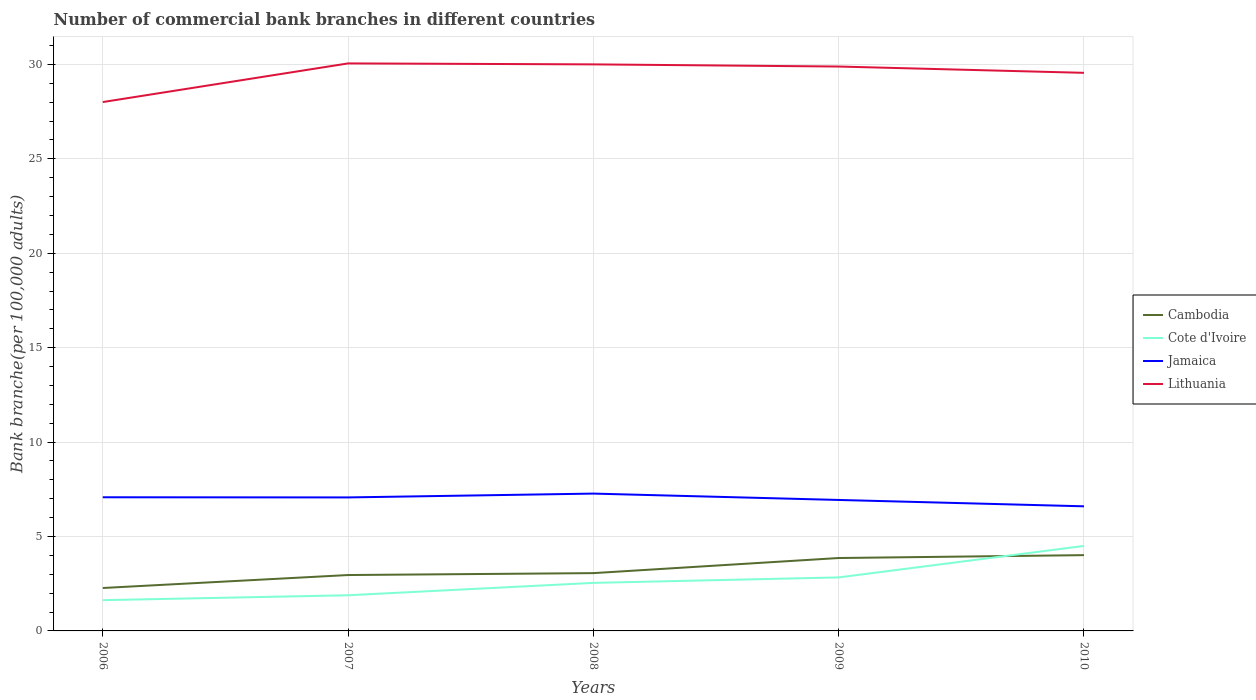Does the line corresponding to Cote d'Ivoire intersect with the line corresponding to Lithuania?
Offer a very short reply. No. Across all years, what is the maximum number of commercial bank branches in Cote d'Ivoire?
Make the answer very short. 1.63. What is the total number of commercial bank branches in Lithuania in the graph?
Offer a very short reply. -1.55. What is the difference between the highest and the second highest number of commercial bank branches in Cote d'Ivoire?
Keep it short and to the point. 2.87. Is the number of commercial bank branches in Cote d'Ivoire strictly greater than the number of commercial bank branches in Lithuania over the years?
Offer a very short reply. Yes. How many lines are there?
Offer a terse response. 4. How many years are there in the graph?
Provide a short and direct response. 5. What is the difference between two consecutive major ticks on the Y-axis?
Your answer should be very brief. 5. Does the graph contain any zero values?
Your response must be concise. No. Does the graph contain grids?
Keep it short and to the point. Yes. What is the title of the graph?
Provide a succinct answer. Number of commercial bank branches in different countries. Does "Australia" appear as one of the legend labels in the graph?
Provide a short and direct response. No. What is the label or title of the X-axis?
Keep it short and to the point. Years. What is the label or title of the Y-axis?
Your answer should be very brief. Bank branche(per 100,0 adults). What is the Bank branche(per 100,000 adults) in Cambodia in 2006?
Your answer should be compact. 2.27. What is the Bank branche(per 100,000 adults) in Cote d'Ivoire in 2006?
Offer a terse response. 1.63. What is the Bank branche(per 100,000 adults) of Jamaica in 2006?
Keep it short and to the point. 7.08. What is the Bank branche(per 100,000 adults) in Lithuania in 2006?
Your answer should be compact. 28.01. What is the Bank branche(per 100,000 adults) in Cambodia in 2007?
Provide a succinct answer. 2.96. What is the Bank branche(per 100,000 adults) of Cote d'Ivoire in 2007?
Your answer should be compact. 1.89. What is the Bank branche(per 100,000 adults) in Jamaica in 2007?
Offer a very short reply. 7.07. What is the Bank branche(per 100,000 adults) of Lithuania in 2007?
Your answer should be very brief. 30.05. What is the Bank branche(per 100,000 adults) in Cambodia in 2008?
Your response must be concise. 3.06. What is the Bank branche(per 100,000 adults) in Cote d'Ivoire in 2008?
Ensure brevity in your answer.  2.54. What is the Bank branche(per 100,000 adults) of Jamaica in 2008?
Your answer should be very brief. 7.27. What is the Bank branche(per 100,000 adults) of Lithuania in 2008?
Keep it short and to the point. 30. What is the Bank branche(per 100,000 adults) in Cambodia in 2009?
Keep it short and to the point. 3.86. What is the Bank branche(per 100,000 adults) in Cote d'Ivoire in 2009?
Ensure brevity in your answer.  2.83. What is the Bank branche(per 100,000 adults) in Jamaica in 2009?
Offer a very short reply. 6.94. What is the Bank branche(per 100,000 adults) in Lithuania in 2009?
Offer a terse response. 29.89. What is the Bank branche(per 100,000 adults) in Cambodia in 2010?
Offer a terse response. 4.01. What is the Bank branche(per 100,000 adults) of Cote d'Ivoire in 2010?
Make the answer very short. 4.5. What is the Bank branche(per 100,000 adults) in Jamaica in 2010?
Your answer should be compact. 6.6. What is the Bank branche(per 100,000 adults) in Lithuania in 2010?
Keep it short and to the point. 29.56. Across all years, what is the maximum Bank branche(per 100,000 adults) of Cambodia?
Ensure brevity in your answer.  4.01. Across all years, what is the maximum Bank branche(per 100,000 adults) in Cote d'Ivoire?
Offer a very short reply. 4.5. Across all years, what is the maximum Bank branche(per 100,000 adults) in Jamaica?
Offer a very short reply. 7.27. Across all years, what is the maximum Bank branche(per 100,000 adults) in Lithuania?
Make the answer very short. 30.05. Across all years, what is the minimum Bank branche(per 100,000 adults) in Cambodia?
Your answer should be very brief. 2.27. Across all years, what is the minimum Bank branche(per 100,000 adults) in Cote d'Ivoire?
Offer a very short reply. 1.63. Across all years, what is the minimum Bank branche(per 100,000 adults) in Jamaica?
Give a very brief answer. 6.6. Across all years, what is the minimum Bank branche(per 100,000 adults) of Lithuania?
Provide a short and direct response. 28.01. What is the total Bank branche(per 100,000 adults) in Cambodia in the graph?
Your answer should be very brief. 16.17. What is the total Bank branche(per 100,000 adults) in Cote d'Ivoire in the graph?
Ensure brevity in your answer.  13.4. What is the total Bank branche(per 100,000 adults) in Jamaica in the graph?
Keep it short and to the point. 34.95. What is the total Bank branche(per 100,000 adults) in Lithuania in the graph?
Keep it short and to the point. 147.51. What is the difference between the Bank branche(per 100,000 adults) in Cambodia in 2006 and that in 2007?
Ensure brevity in your answer.  -0.69. What is the difference between the Bank branche(per 100,000 adults) in Cote d'Ivoire in 2006 and that in 2007?
Give a very brief answer. -0.26. What is the difference between the Bank branche(per 100,000 adults) of Jamaica in 2006 and that in 2007?
Provide a short and direct response. 0.01. What is the difference between the Bank branche(per 100,000 adults) in Lithuania in 2006 and that in 2007?
Make the answer very short. -2.05. What is the difference between the Bank branche(per 100,000 adults) of Cambodia in 2006 and that in 2008?
Make the answer very short. -0.79. What is the difference between the Bank branche(per 100,000 adults) of Cote d'Ivoire in 2006 and that in 2008?
Your answer should be very brief. -0.92. What is the difference between the Bank branche(per 100,000 adults) of Jamaica in 2006 and that in 2008?
Your answer should be compact. -0.19. What is the difference between the Bank branche(per 100,000 adults) in Lithuania in 2006 and that in 2008?
Make the answer very short. -2. What is the difference between the Bank branche(per 100,000 adults) of Cambodia in 2006 and that in 2009?
Provide a short and direct response. -1.59. What is the difference between the Bank branche(per 100,000 adults) of Cote d'Ivoire in 2006 and that in 2009?
Provide a succinct answer. -1.21. What is the difference between the Bank branche(per 100,000 adults) of Jamaica in 2006 and that in 2009?
Provide a succinct answer. 0.14. What is the difference between the Bank branche(per 100,000 adults) in Lithuania in 2006 and that in 2009?
Ensure brevity in your answer.  -1.88. What is the difference between the Bank branche(per 100,000 adults) in Cambodia in 2006 and that in 2010?
Your response must be concise. -1.74. What is the difference between the Bank branche(per 100,000 adults) of Cote d'Ivoire in 2006 and that in 2010?
Make the answer very short. -2.87. What is the difference between the Bank branche(per 100,000 adults) in Jamaica in 2006 and that in 2010?
Keep it short and to the point. 0.48. What is the difference between the Bank branche(per 100,000 adults) in Lithuania in 2006 and that in 2010?
Ensure brevity in your answer.  -1.55. What is the difference between the Bank branche(per 100,000 adults) in Cambodia in 2007 and that in 2008?
Offer a very short reply. -0.1. What is the difference between the Bank branche(per 100,000 adults) in Cote d'Ivoire in 2007 and that in 2008?
Give a very brief answer. -0.65. What is the difference between the Bank branche(per 100,000 adults) of Jamaica in 2007 and that in 2008?
Make the answer very short. -0.2. What is the difference between the Bank branche(per 100,000 adults) of Lithuania in 2007 and that in 2008?
Your response must be concise. 0.05. What is the difference between the Bank branche(per 100,000 adults) in Cambodia in 2007 and that in 2009?
Your answer should be very brief. -0.9. What is the difference between the Bank branche(per 100,000 adults) in Cote d'Ivoire in 2007 and that in 2009?
Your answer should be very brief. -0.94. What is the difference between the Bank branche(per 100,000 adults) in Jamaica in 2007 and that in 2009?
Ensure brevity in your answer.  0.13. What is the difference between the Bank branche(per 100,000 adults) in Lithuania in 2007 and that in 2009?
Offer a terse response. 0.16. What is the difference between the Bank branche(per 100,000 adults) of Cambodia in 2007 and that in 2010?
Your answer should be compact. -1.05. What is the difference between the Bank branche(per 100,000 adults) of Cote d'Ivoire in 2007 and that in 2010?
Provide a short and direct response. -2.61. What is the difference between the Bank branche(per 100,000 adults) in Jamaica in 2007 and that in 2010?
Keep it short and to the point. 0.47. What is the difference between the Bank branche(per 100,000 adults) in Lithuania in 2007 and that in 2010?
Provide a succinct answer. 0.5. What is the difference between the Bank branche(per 100,000 adults) of Cambodia in 2008 and that in 2009?
Provide a short and direct response. -0.8. What is the difference between the Bank branche(per 100,000 adults) in Cote d'Ivoire in 2008 and that in 2009?
Make the answer very short. -0.29. What is the difference between the Bank branche(per 100,000 adults) in Jamaica in 2008 and that in 2009?
Your answer should be very brief. 0.34. What is the difference between the Bank branche(per 100,000 adults) of Lithuania in 2008 and that in 2009?
Ensure brevity in your answer.  0.11. What is the difference between the Bank branche(per 100,000 adults) in Cambodia in 2008 and that in 2010?
Ensure brevity in your answer.  -0.95. What is the difference between the Bank branche(per 100,000 adults) in Cote d'Ivoire in 2008 and that in 2010?
Your response must be concise. -1.96. What is the difference between the Bank branche(per 100,000 adults) of Jamaica in 2008 and that in 2010?
Your response must be concise. 0.67. What is the difference between the Bank branche(per 100,000 adults) of Lithuania in 2008 and that in 2010?
Provide a short and direct response. 0.45. What is the difference between the Bank branche(per 100,000 adults) of Cambodia in 2009 and that in 2010?
Offer a very short reply. -0.15. What is the difference between the Bank branche(per 100,000 adults) of Cote d'Ivoire in 2009 and that in 2010?
Your answer should be compact. -1.67. What is the difference between the Bank branche(per 100,000 adults) of Jamaica in 2009 and that in 2010?
Give a very brief answer. 0.34. What is the difference between the Bank branche(per 100,000 adults) of Lithuania in 2009 and that in 2010?
Give a very brief answer. 0.33. What is the difference between the Bank branche(per 100,000 adults) of Cambodia in 2006 and the Bank branche(per 100,000 adults) of Cote d'Ivoire in 2007?
Give a very brief answer. 0.38. What is the difference between the Bank branche(per 100,000 adults) in Cambodia in 2006 and the Bank branche(per 100,000 adults) in Jamaica in 2007?
Offer a very short reply. -4.8. What is the difference between the Bank branche(per 100,000 adults) in Cambodia in 2006 and the Bank branche(per 100,000 adults) in Lithuania in 2007?
Your answer should be very brief. -27.78. What is the difference between the Bank branche(per 100,000 adults) in Cote d'Ivoire in 2006 and the Bank branche(per 100,000 adults) in Jamaica in 2007?
Offer a very short reply. -5.44. What is the difference between the Bank branche(per 100,000 adults) in Cote d'Ivoire in 2006 and the Bank branche(per 100,000 adults) in Lithuania in 2007?
Ensure brevity in your answer.  -28.43. What is the difference between the Bank branche(per 100,000 adults) in Jamaica in 2006 and the Bank branche(per 100,000 adults) in Lithuania in 2007?
Provide a short and direct response. -22.98. What is the difference between the Bank branche(per 100,000 adults) in Cambodia in 2006 and the Bank branche(per 100,000 adults) in Cote d'Ivoire in 2008?
Keep it short and to the point. -0.27. What is the difference between the Bank branche(per 100,000 adults) in Cambodia in 2006 and the Bank branche(per 100,000 adults) in Jamaica in 2008?
Keep it short and to the point. -5. What is the difference between the Bank branche(per 100,000 adults) of Cambodia in 2006 and the Bank branche(per 100,000 adults) of Lithuania in 2008?
Give a very brief answer. -27.73. What is the difference between the Bank branche(per 100,000 adults) in Cote d'Ivoire in 2006 and the Bank branche(per 100,000 adults) in Jamaica in 2008?
Provide a succinct answer. -5.64. What is the difference between the Bank branche(per 100,000 adults) of Cote d'Ivoire in 2006 and the Bank branche(per 100,000 adults) of Lithuania in 2008?
Offer a terse response. -28.38. What is the difference between the Bank branche(per 100,000 adults) in Jamaica in 2006 and the Bank branche(per 100,000 adults) in Lithuania in 2008?
Give a very brief answer. -22.93. What is the difference between the Bank branche(per 100,000 adults) in Cambodia in 2006 and the Bank branche(per 100,000 adults) in Cote d'Ivoire in 2009?
Offer a very short reply. -0.56. What is the difference between the Bank branche(per 100,000 adults) of Cambodia in 2006 and the Bank branche(per 100,000 adults) of Jamaica in 2009?
Give a very brief answer. -4.66. What is the difference between the Bank branche(per 100,000 adults) in Cambodia in 2006 and the Bank branche(per 100,000 adults) in Lithuania in 2009?
Your response must be concise. -27.62. What is the difference between the Bank branche(per 100,000 adults) of Cote d'Ivoire in 2006 and the Bank branche(per 100,000 adults) of Jamaica in 2009?
Provide a short and direct response. -5.31. What is the difference between the Bank branche(per 100,000 adults) in Cote d'Ivoire in 2006 and the Bank branche(per 100,000 adults) in Lithuania in 2009?
Provide a succinct answer. -28.26. What is the difference between the Bank branche(per 100,000 adults) in Jamaica in 2006 and the Bank branche(per 100,000 adults) in Lithuania in 2009?
Offer a very short reply. -22.81. What is the difference between the Bank branche(per 100,000 adults) in Cambodia in 2006 and the Bank branche(per 100,000 adults) in Cote d'Ivoire in 2010?
Your answer should be very brief. -2.23. What is the difference between the Bank branche(per 100,000 adults) in Cambodia in 2006 and the Bank branche(per 100,000 adults) in Jamaica in 2010?
Make the answer very short. -4.33. What is the difference between the Bank branche(per 100,000 adults) of Cambodia in 2006 and the Bank branche(per 100,000 adults) of Lithuania in 2010?
Your response must be concise. -27.28. What is the difference between the Bank branche(per 100,000 adults) in Cote d'Ivoire in 2006 and the Bank branche(per 100,000 adults) in Jamaica in 2010?
Your response must be concise. -4.97. What is the difference between the Bank branche(per 100,000 adults) in Cote d'Ivoire in 2006 and the Bank branche(per 100,000 adults) in Lithuania in 2010?
Keep it short and to the point. -27.93. What is the difference between the Bank branche(per 100,000 adults) in Jamaica in 2006 and the Bank branche(per 100,000 adults) in Lithuania in 2010?
Keep it short and to the point. -22.48. What is the difference between the Bank branche(per 100,000 adults) of Cambodia in 2007 and the Bank branche(per 100,000 adults) of Cote d'Ivoire in 2008?
Offer a very short reply. 0.42. What is the difference between the Bank branche(per 100,000 adults) in Cambodia in 2007 and the Bank branche(per 100,000 adults) in Jamaica in 2008?
Offer a very short reply. -4.31. What is the difference between the Bank branche(per 100,000 adults) of Cambodia in 2007 and the Bank branche(per 100,000 adults) of Lithuania in 2008?
Give a very brief answer. -27.04. What is the difference between the Bank branche(per 100,000 adults) of Cote d'Ivoire in 2007 and the Bank branche(per 100,000 adults) of Jamaica in 2008?
Keep it short and to the point. -5.38. What is the difference between the Bank branche(per 100,000 adults) of Cote d'Ivoire in 2007 and the Bank branche(per 100,000 adults) of Lithuania in 2008?
Provide a succinct answer. -28.11. What is the difference between the Bank branche(per 100,000 adults) of Jamaica in 2007 and the Bank branche(per 100,000 adults) of Lithuania in 2008?
Offer a very short reply. -22.93. What is the difference between the Bank branche(per 100,000 adults) in Cambodia in 2007 and the Bank branche(per 100,000 adults) in Cote d'Ivoire in 2009?
Keep it short and to the point. 0.13. What is the difference between the Bank branche(per 100,000 adults) in Cambodia in 2007 and the Bank branche(per 100,000 adults) in Jamaica in 2009?
Your response must be concise. -3.98. What is the difference between the Bank branche(per 100,000 adults) in Cambodia in 2007 and the Bank branche(per 100,000 adults) in Lithuania in 2009?
Keep it short and to the point. -26.93. What is the difference between the Bank branche(per 100,000 adults) of Cote d'Ivoire in 2007 and the Bank branche(per 100,000 adults) of Jamaica in 2009?
Your response must be concise. -5.05. What is the difference between the Bank branche(per 100,000 adults) of Cote d'Ivoire in 2007 and the Bank branche(per 100,000 adults) of Lithuania in 2009?
Your response must be concise. -28. What is the difference between the Bank branche(per 100,000 adults) in Jamaica in 2007 and the Bank branche(per 100,000 adults) in Lithuania in 2009?
Offer a very short reply. -22.82. What is the difference between the Bank branche(per 100,000 adults) in Cambodia in 2007 and the Bank branche(per 100,000 adults) in Cote d'Ivoire in 2010?
Provide a succinct answer. -1.54. What is the difference between the Bank branche(per 100,000 adults) in Cambodia in 2007 and the Bank branche(per 100,000 adults) in Jamaica in 2010?
Ensure brevity in your answer.  -3.64. What is the difference between the Bank branche(per 100,000 adults) in Cambodia in 2007 and the Bank branche(per 100,000 adults) in Lithuania in 2010?
Your answer should be very brief. -26.6. What is the difference between the Bank branche(per 100,000 adults) in Cote d'Ivoire in 2007 and the Bank branche(per 100,000 adults) in Jamaica in 2010?
Give a very brief answer. -4.71. What is the difference between the Bank branche(per 100,000 adults) in Cote d'Ivoire in 2007 and the Bank branche(per 100,000 adults) in Lithuania in 2010?
Make the answer very short. -27.67. What is the difference between the Bank branche(per 100,000 adults) in Jamaica in 2007 and the Bank branche(per 100,000 adults) in Lithuania in 2010?
Give a very brief answer. -22.49. What is the difference between the Bank branche(per 100,000 adults) in Cambodia in 2008 and the Bank branche(per 100,000 adults) in Cote d'Ivoire in 2009?
Your answer should be very brief. 0.23. What is the difference between the Bank branche(per 100,000 adults) of Cambodia in 2008 and the Bank branche(per 100,000 adults) of Jamaica in 2009?
Ensure brevity in your answer.  -3.87. What is the difference between the Bank branche(per 100,000 adults) in Cambodia in 2008 and the Bank branche(per 100,000 adults) in Lithuania in 2009?
Offer a very short reply. -26.83. What is the difference between the Bank branche(per 100,000 adults) of Cote d'Ivoire in 2008 and the Bank branche(per 100,000 adults) of Jamaica in 2009?
Make the answer very short. -4.39. What is the difference between the Bank branche(per 100,000 adults) of Cote d'Ivoire in 2008 and the Bank branche(per 100,000 adults) of Lithuania in 2009?
Make the answer very short. -27.35. What is the difference between the Bank branche(per 100,000 adults) in Jamaica in 2008 and the Bank branche(per 100,000 adults) in Lithuania in 2009?
Make the answer very short. -22.62. What is the difference between the Bank branche(per 100,000 adults) in Cambodia in 2008 and the Bank branche(per 100,000 adults) in Cote d'Ivoire in 2010?
Your answer should be very brief. -1.44. What is the difference between the Bank branche(per 100,000 adults) of Cambodia in 2008 and the Bank branche(per 100,000 adults) of Jamaica in 2010?
Make the answer very short. -3.54. What is the difference between the Bank branche(per 100,000 adults) of Cambodia in 2008 and the Bank branche(per 100,000 adults) of Lithuania in 2010?
Keep it short and to the point. -26.5. What is the difference between the Bank branche(per 100,000 adults) of Cote d'Ivoire in 2008 and the Bank branche(per 100,000 adults) of Jamaica in 2010?
Ensure brevity in your answer.  -4.05. What is the difference between the Bank branche(per 100,000 adults) in Cote d'Ivoire in 2008 and the Bank branche(per 100,000 adults) in Lithuania in 2010?
Give a very brief answer. -27.01. What is the difference between the Bank branche(per 100,000 adults) in Jamaica in 2008 and the Bank branche(per 100,000 adults) in Lithuania in 2010?
Provide a short and direct response. -22.28. What is the difference between the Bank branche(per 100,000 adults) in Cambodia in 2009 and the Bank branche(per 100,000 adults) in Cote d'Ivoire in 2010?
Provide a succinct answer. -0.64. What is the difference between the Bank branche(per 100,000 adults) in Cambodia in 2009 and the Bank branche(per 100,000 adults) in Jamaica in 2010?
Provide a succinct answer. -2.74. What is the difference between the Bank branche(per 100,000 adults) of Cambodia in 2009 and the Bank branche(per 100,000 adults) of Lithuania in 2010?
Offer a very short reply. -25.7. What is the difference between the Bank branche(per 100,000 adults) in Cote d'Ivoire in 2009 and the Bank branche(per 100,000 adults) in Jamaica in 2010?
Provide a short and direct response. -3.76. What is the difference between the Bank branche(per 100,000 adults) in Cote d'Ivoire in 2009 and the Bank branche(per 100,000 adults) in Lithuania in 2010?
Offer a terse response. -26.72. What is the difference between the Bank branche(per 100,000 adults) in Jamaica in 2009 and the Bank branche(per 100,000 adults) in Lithuania in 2010?
Offer a very short reply. -22.62. What is the average Bank branche(per 100,000 adults) of Cambodia per year?
Keep it short and to the point. 3.23. What is the average Bank branche(per 100,000 adults) of Cote d'Ivoire per year?
Your answer should be compact. 2.68. What is the average Bank branche(per 100,000 adults) in Jamaica per year?
Keep it short and to the point. 6.99. What is the average Bank branche(per 100,000 adults) in Lithuania per year?
Provide a succinct answer. 29.5. In the year 2006, what is the difference between the Bank branche(per 100,000 adults) of Cambodia and Bank branche(per 100,000 adults) of Cote d'Ivoire?
Your answer should be compact. 0.65. In the year 2006, what is the difference between the Bank branche(per 100,000 adults) in Cambodia and Bank branche(per 100,000 adults) in Jamaica?
Offer a very short reply. -4.8. In the year 2006, what is the difference between the Bank branche(per 100,000 adults) of Cambodia and Bank branche(per 100,000 adults) of Lithuania?
Make the answer very short. -25.73. In the year 2006, what is the difference between the Bank branche(per 100,000 adults) in Cote d'Ivoire and Bank branche(per 100,000 adults) in Jamaica?
Provide a short and direct response. -5.45. In the year 2006, what is the difference between the Bank branche(per 100,000 adults) in Cote d'Ivoire and Bank branche(per 100,000 adults) in Lithuania?
Keep it short and to the point. -26.38. In the year 2006, what is the difference between the Bank branche(per 100,000 adults) in Jamaica and Bank branche(per 100,000 adults) in Lithuania?
Provide a succinct answer. -20.93. In the year 2007, what is the difference between the Bank branche(per 100,000 adults) in Cambodia and Bank branche(per 100,000 adults) in Cote d'Ivoire?
Your response must be concise. 1.07. In the year 2007, what is the difference between the Bank branche(per 100,000 adults) in Cambodia and Bank branche(per 100,000 adults) in Jamaica?
Your answer should be very brief. -4.11. In the year 2007, what is the difference between the Bank branche(per 100,000 adults) of Cambodia and Bank branche(per 100,000 adults) of Lithuania?
Keep it short and to the point. -27.1. In the year 2007, what is the difference between the Bank branche(per 100,000 adults) of Cote d'Ivoire and Bank branche(per 100,000 adults) of Jamaica?
Ensure brevity in your answer.  -5.18. In the year 2007, what is the difference between the Bank branche(per 100,000 adults) of Cote d'Ivoire and Bank branche(per 100,000 adults) of Lithuania?
Your answer should be compact. -28.17. In the year 2007, what is the difference between the Bank branche(per 100,000 adults) of Jamaica and Bank branche(per 100,000 adults) of Lithuania?
Offer a terse response. -22.98. In the year 2008, what is the difference between the Bank branche(per 100,000 adults) of Cambodia and Bank branche(per 100,000 adults) of Cote d'Ivoire?
Give a very brief answer. 0.52. In the year 2008, what is the difference between the Bank branche(per 100,000 adults) in Cambodia and Bank branche(per 100,000 adults) in Jamaica?
Make the answer very short. -4.21. In the year 2008, what is the difference between the Bank branche(per 100,000 adults) in Cambodia and Bank branche(per 100,000 adults) in Lithuania?
Your response must be concise. -26.94. In the year 2008, what is the difference between the Bank branche(per 100,000 adults) in Cote d'Ivoire and Bank branche(per 100,000 adults) in Jamaica?
Make the answer very short. -4.73. In the year 2008, what is the difference between the Bank branche(per 100,000 adults) of Cote d'Ivoire and Bank branche(per 100,000 adults) of Lithuania?
Keep it short and to the point. -27.46. In the year 2008, what is the difference between the Bank branche(per 100,000 adults) in Jamaica and Bank branche(per 100,000 adults) in Lithuania?
Offer a terse response. -22.73. In the year 2009, what is the difference between the Bank branche(per 100,000 adults) in Cambodia and Bank branche(per 100,000 adults) in Cote d'Ivoire?
Provide a short and direct response. 1.03. In the year 2009, what is the difference between the Bank branche(per 100,000 adults) of Cambodia and Bank branche(per 100,000 adults) of Jamaica?
Offer a very short reply. -3.07. In the year 2009, what is the difference between the Bank branche(per 100,000 adults) in Cambodia and Bank branche(per 100,000 adults) in Lithuania?
Give a very brief answer. -26.03. In the year 2009, what is the difference between the Bank branche(per 100,000 adults) of Cote d'Ivoire and Bank branche(per 100,000 adults) of Jamaica?
Your answer should be very brief. -4.1. In the year 2009, what is the difference between the Bank branche(per 100,000 adults) in Cote d'Ivoire and Bank branche(per 100,000 adults) in Lithuania?
Your response must be concise. -27.06. In the year 2009, what is the difference between the Bank branche(per 100,000 adults) of Jamaica and Bank branche(per 100,000 adults) of Lithuania?
Your answer should be very brief. -22.95. In the year 2010, what is the difference between the Bank branche(per 100,000 adults) of Cambodia and Bank branche(per 100,000 adults) of Cote d'Ivoire?
Give a very brief answer. -0.49. In the year 2010, what is the difference between the Bank branche(per 100,000 adults) in Cambodia and Bank branche(per 100,000 adults) in Jamaica?
Provide a succinct answer. -2.59. In the year 2010, what is the difference between the Bank branche(per 100,000 adults) in Cambodia and Bank branche(per 100,000 adults) in Lithuania?
Offer a very short reply. -25.54. In the year 2010, what is the difference between the Bank branche(per 100,000 adults) in Cote d'Ivoire and Bank branche(per 100,000 adults) in Jamaica?
Make the answer very short. -2.1. In the year 2010, what is the difference between the Bank branche(per 100,000 adults) of Cote d'Ivoire and Bank branche(per 100,000 adults) of Lithuania?
Ensure brevity in your answer.  -25.06. In the year 2010, what is the difference between the Bank branche(per 100,000 adults) in Jamaica and Bank branche(per 100,000 adults) in Lithuania?
Ensure brevity in your answer.  -22.96. What is the ratio of the Bank branche(per 100,000 adults) in Cambodia in 2006 to that in 2007?
Your response must be concise. 0.77. What is the ratio of the Bank branche(per 100,000 adults) of Cote d'Ivoire in 2006 to that in 2007?
Provide a short and direct response. 0.86. What is the ratio of the Bank branche(per 100,000 adults) in Lithuania in 2006 to that in 2007?
Keep it short and to the point. 0.93. What is the ratio of the Bank branche(per 100,000 adults) of Cambodia in 2006 to that in 2008?
Give a very brief answer. 0.74. What is the ratio of the Bank branche(per 100,000 adults) in Cote d'Ivoire in 2006 to that in 2008?
Make the answer very short. 0.64. What is the ratio of the Bank branche(per 100,000 adults) of Jamaica in 2006 to that in 2008?
Make the answer very short. 0.97. What is the ratio of the Bank branche(per 100,000 adults) in Lithuania in 2006 to that in 2008?
Your answer should be compact. 0.93. What is the ratio of the Bank branche(per 100,000 adults) in Cambodia in 2006 to that in 2009?
Your answer should be very brief. 0.59. What is the ratio of the Bank branche(per 100,000 adults) of Cote d'Ivoire in 2006 to that in 2009?
Make the answer very short. 0.57. What is the ratio of the Bank branche(per 100,000 adults) of Jamaica in 2006 to that in 2009?
Your answer should be compact. 1.02. What is the ratio of the Bank branche(per 100,000 adults) of Lithuania in 2006 to that in 2009?
Keep it short and to the point. 0.94. What is the ratio of the Bank branche(per 100,000 adults) in Cambodia in 2006 to that in 2010?
Provide a succinct answer. 0.57. What is the ratio of the Bank branche(per 100,000 adults) in Cote d'Ivoire in 2006 to that in 2010?
Offer a terse response. 0.36. What is the ratio of the Bank branche(per 100,000 adults) of Jamaica in 2006 to that in 2010?
Offer a very short reply. 1.07. What is the ratio of the Bank branche(per 100,000 adults) of Lithuania in 2006 to that in 2010?
Provide a succinct answer. 0.95. What is the ratio of the Bank branche(per 100,000 adults) of Cambodia in 2007 to that in 2008?
Give a very brief answer. 0.97. What is the ratio of the Bank branche(per 100,000 adults) of Cote d'Ivoire in 2007 to that in 2008?
Your response must be concise. 0.74. What is the ratio of the Bank branche(per 100,000 adults) of Jamaica in 2007 to that in 2008?
Your answer should be compact. 0.97. What is the ratio of the Bank branche(per 100,000 adults) in Cambodia in 2007 to that in 2009?
Your answer should be compact. 0.77. What is the ratio of the Bank branche(per 100,000 adults) of Cote d'Ivoire in 2007 to that in 2009?
Offer a terse response. 0.67. What is the ratio of the Bank branche(per 100,000 adults) in Jamaica in 2007 to that in 2009?
Make the answer very short. 1.02. What is the ratio of the Bank branche(per 100,000 adults) of Cambodia in 2007 to that in 2010?
Make the answer very short. 0.74. What is the ratio of the Bank branche(per 100,000 adults) in Cote d'Ivoire in 2007 to that in 2010?
Offer a terse response. 0.42. What is the ratio of the Bank branche(per 100,000 adults) in Jamaica in 2007 to that in 2010?
Provide a short and direct response. 1.07. What is the ratio of the Bank branche(per 100,000 adults) in Lithuania in 2007 to that in 2010?
Provide a short and direct response. 1.02. What is the ratio of the Bank branche(per 100,000 adults) in Cambodia in 2008 to that in 2009?
Give a very brief answer. 0.79. What is the ratio of the Bank branche(per 100,000 adults) in Cote d'Ivoire in 2008 to that in 2009?
Offer a very short reply. 0.9. What is the ratio of the Bank branche(per 100,000 adults) in Jamaica in 2008 to that in 2009?
Provide a short and direct response. 1.05. What is the ratio of the Bank branche(per 100,000 adults) in Lithuania in 2008 to that in 2009?
Provide a succinct answer. 1. What is the ratio of the Bank branche(per 100,000 adults) of Cambodia in 2008 to that in 2010?
Ensure brevity in your answer.  0.76. What is the ratio of the Bank branche(per 100,000 adults) of Cote d'Ivoire in 2008 to that in 2010?
Your answer should be compact. 0.57. What is the ratio of the Bank branche(per 100,000 adults) in Jamaica in 2008 to that in 2010?
Your answer should be compact. 1.1. What is the ratio of the Bank branche(per 100,000 adults) in Lithuania in 2008 to that in 2010?
Your answer should be compact. 1.02. What is the ratio of the Bank branche(per 100,000 adults) in Cambodia in 2009 to that in 2010?
Keep it short and to the point. 0.96. What is the ratio of the Bank branche(per 100,000 adults) of Cote d'Ivoire in 2009 to that in 2010?
Your answer should be very brief. 0.63. What is the ratio of the Bank branche(per 100,000 adults) of Jamaica in 2009 to that in 2010?
Give a very brief answer. 1.05. What is the ratio of the Bank branche(per 100,000 adults) in Lithuania in 2009 to that in 2010?
Ensure brevity in your answer.  1.01. What is the difference between the highest and the second highest Bank branche(per 100,000 adults) in Cambodia?
Provide a succinct answer. 0.15. What is the difference between the highest and the second highest Bank branche(per 100,000 adults) in Cote d'Ivoire?
Your answer should be very brief. 1.67. What is the difference between the highest and the second highest Bank branche(per 100,000 adults) of Jamaica?
Give a very brief answer. 0.19. What is the difference between the highest and the second highest Bank branche(per 100,000 adults) of Lithuania?
Offer a very short reply. 0.05. What is the difference between the highest and the lowest Bank branche(per 100,000 adults) in Cambodia?
Offer a very short reply. 1.74. What is the difference between the highest and the lowest Bank branche(per 100,000 adults) of Cote d'Ivoire?
Ensure brevity in your answer.  2.87. What is the difference between the highest and the lowest Bank branche(per 100,000 adults) in Jamaica?
Your answer should be compact. 0.67. What is the difference between the highest and the lowest Bank branche(per 100,000 adults) in Lithuania?
Ensure brevity in your answer.  2.05. 